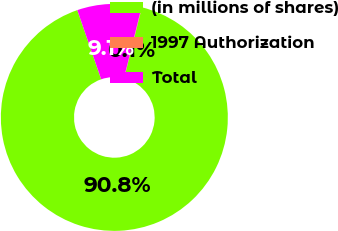Convert chart. <chart><loc_0><loc_0><loc_500><loc_500><pie_chart><fcel>(in millions of shares)<fcel>1997 Authorization<fcel>Total<nl><fcel>90.8%<fcel>0.06%<fcel>9.14%<nl></chart> 